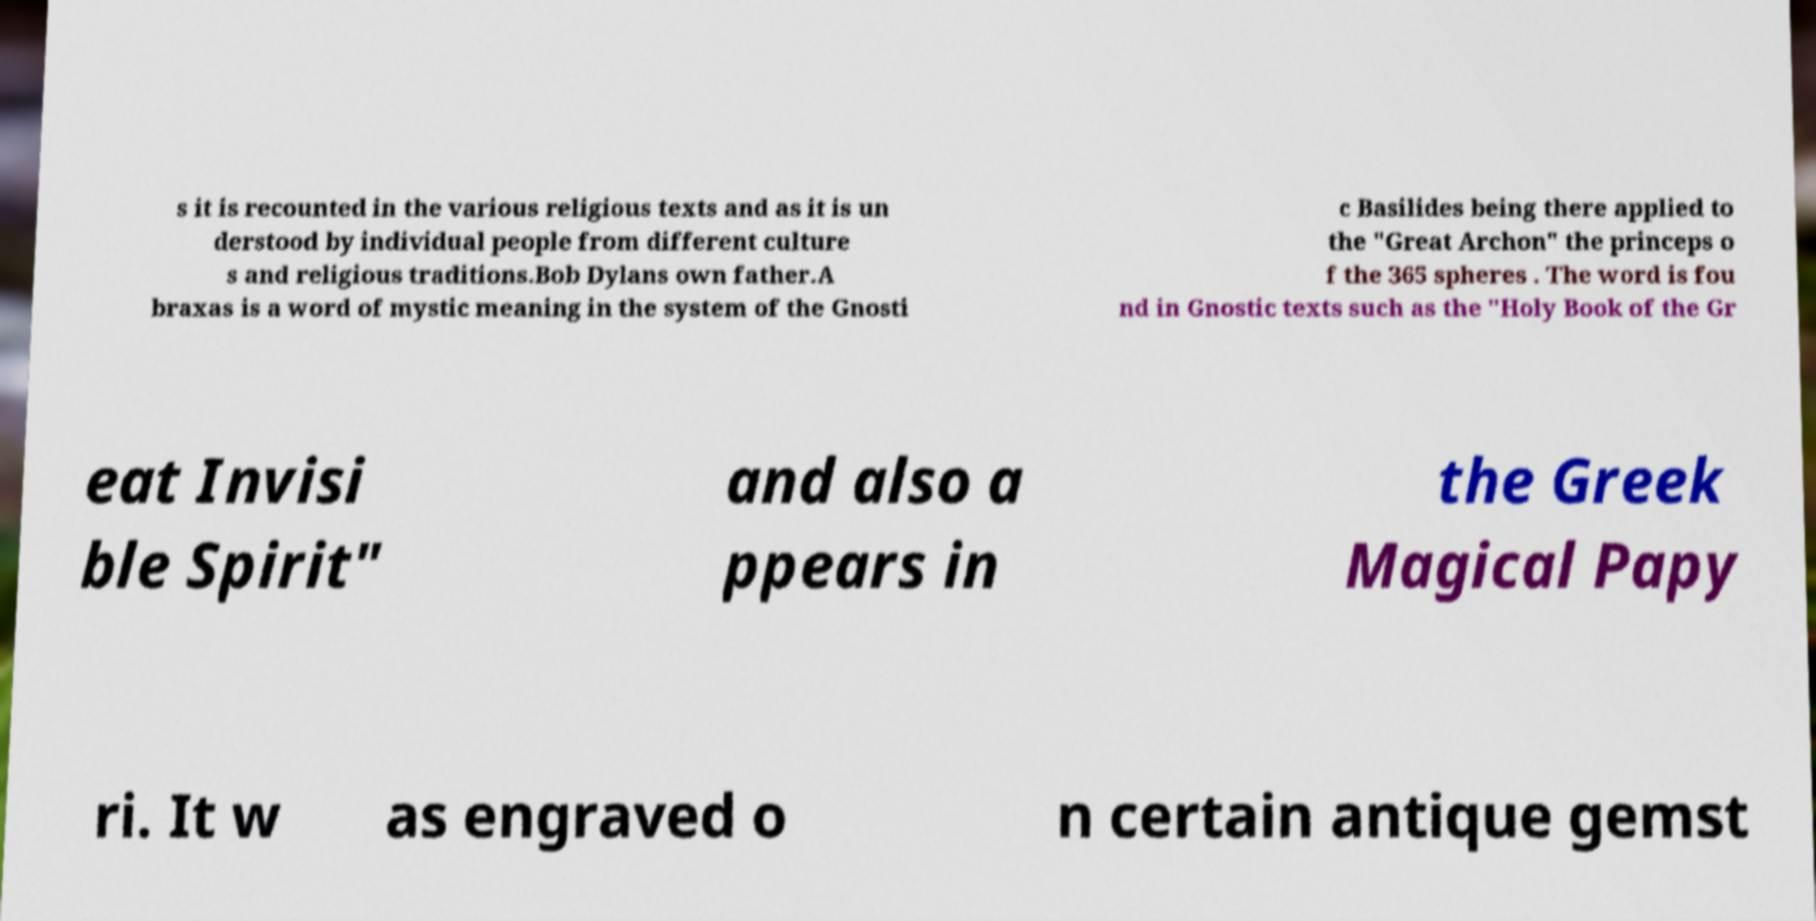Please read and relay the text visible in this image. What does it say? s it is recounted in the various religious texts and as it is un derstood by individual people from different culture s and religious traditions.Bob Dylans own father.A braxas is a word of mystic meaning in the system of the Gnosti c Basilides being there applied to the "Great Archon" the princeps o f the 365 spheres . The word is fou nd in Gnostic texts such as the "Holy Book of the Gr eat Invisi ble Spirit" and also a ppears in the Greek Magical Papy ri. It w as engraved o n certain antique gemst 